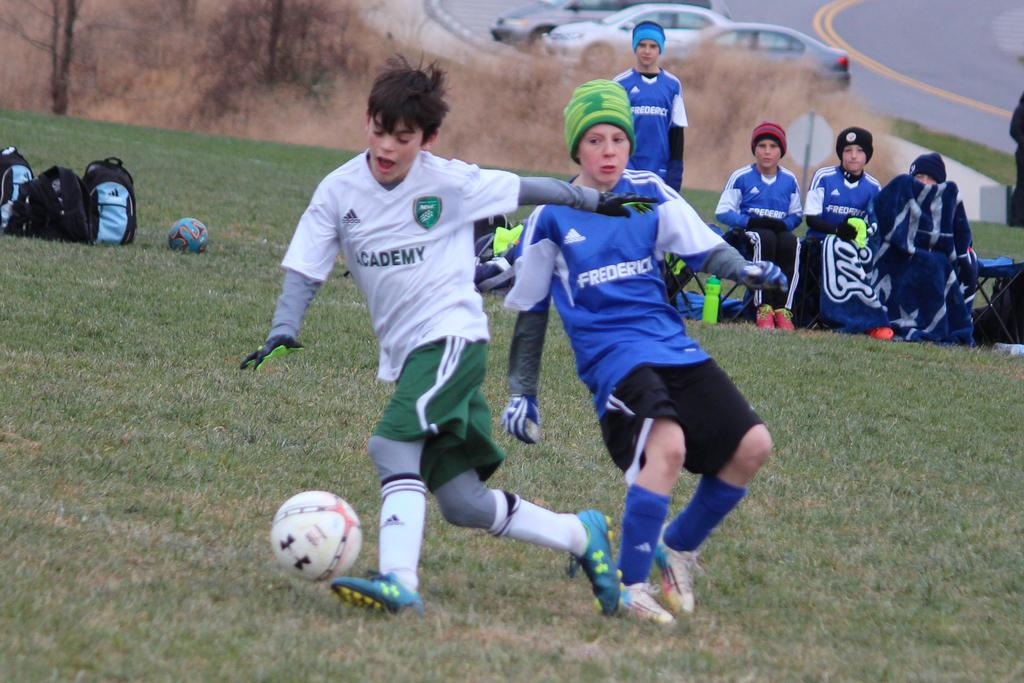<image>
Share a concise interpretation of the image provided. The player in white has academy written on their top. 